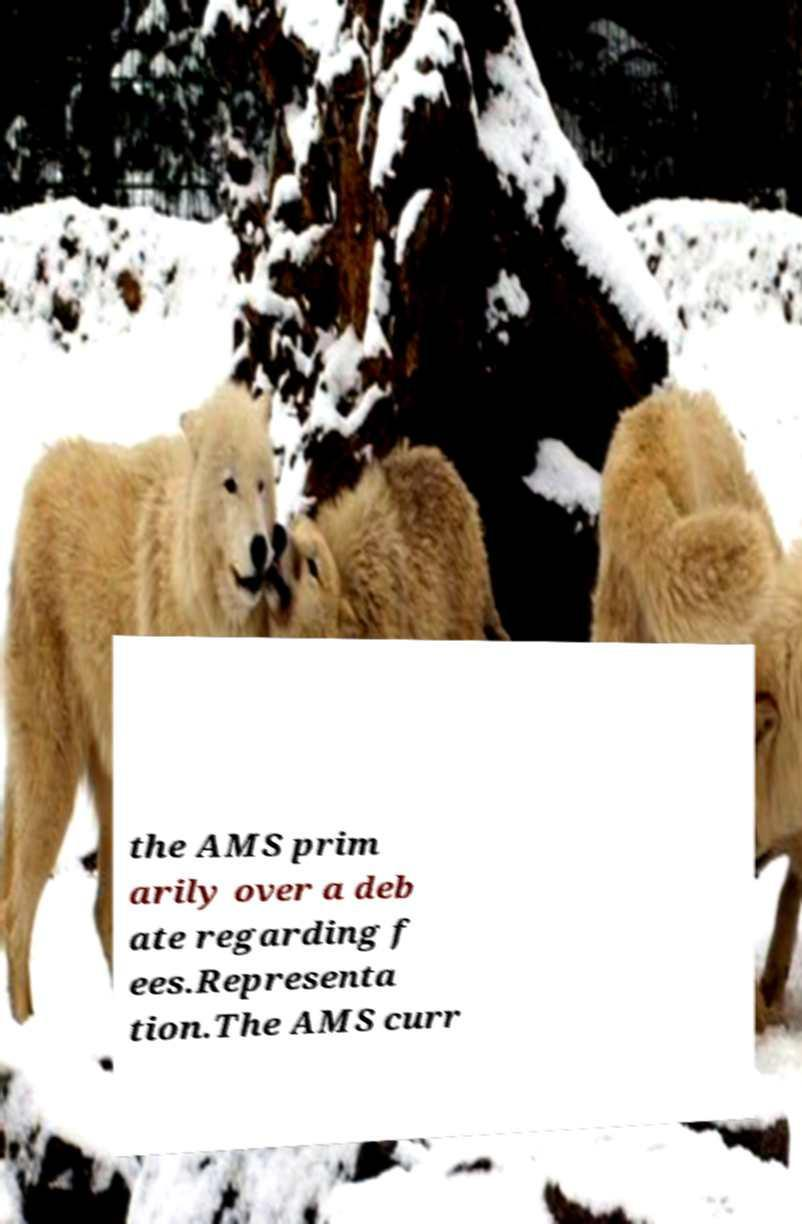Could you extract and type out the text from this image? the AMS prim arily over a deb ate regarding f ees.Representa tion.The AMS curr 